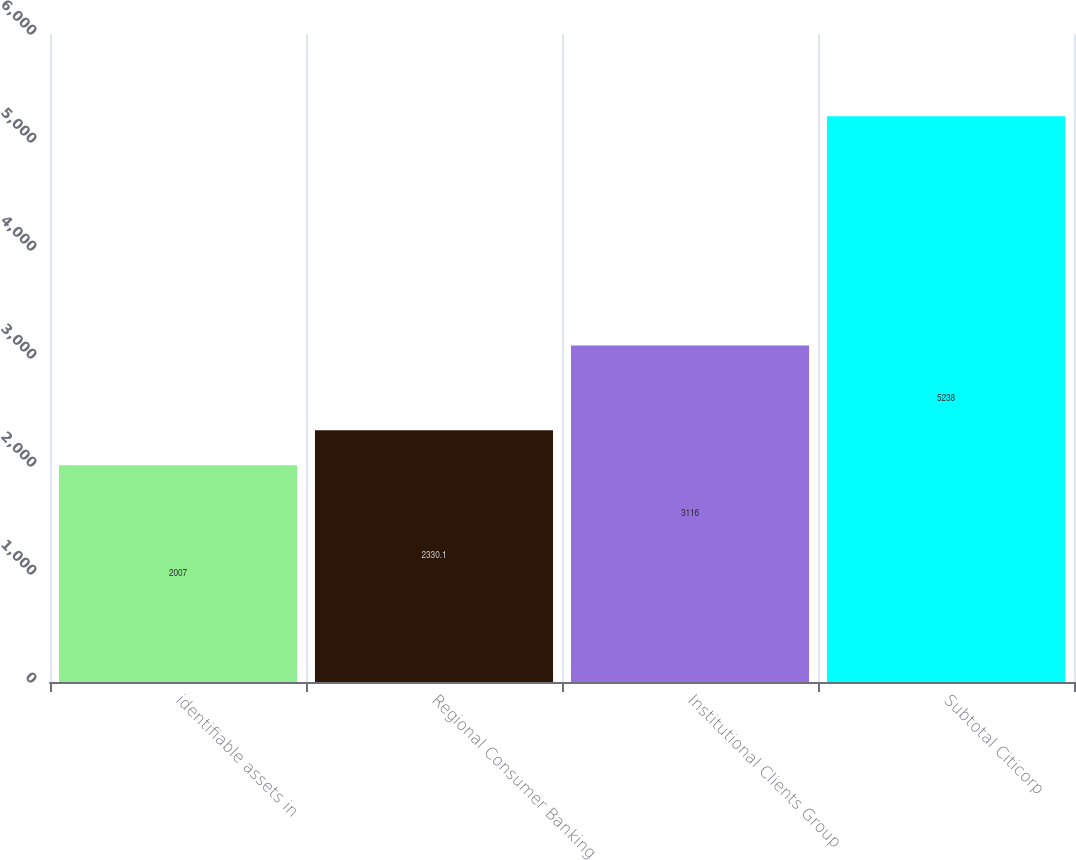<chart> <loc_0><loc_0><loc_500><loc_500><bar_chart><fcel>identifiable assets in<fcel>Regional Consumer Banking<fcel>Institutional Clients Group<fcel>Subtotal Citicorp<nl><fcel>2007<fcel>2330.1<fcel>3116<fcel>5238<nl></chart> 